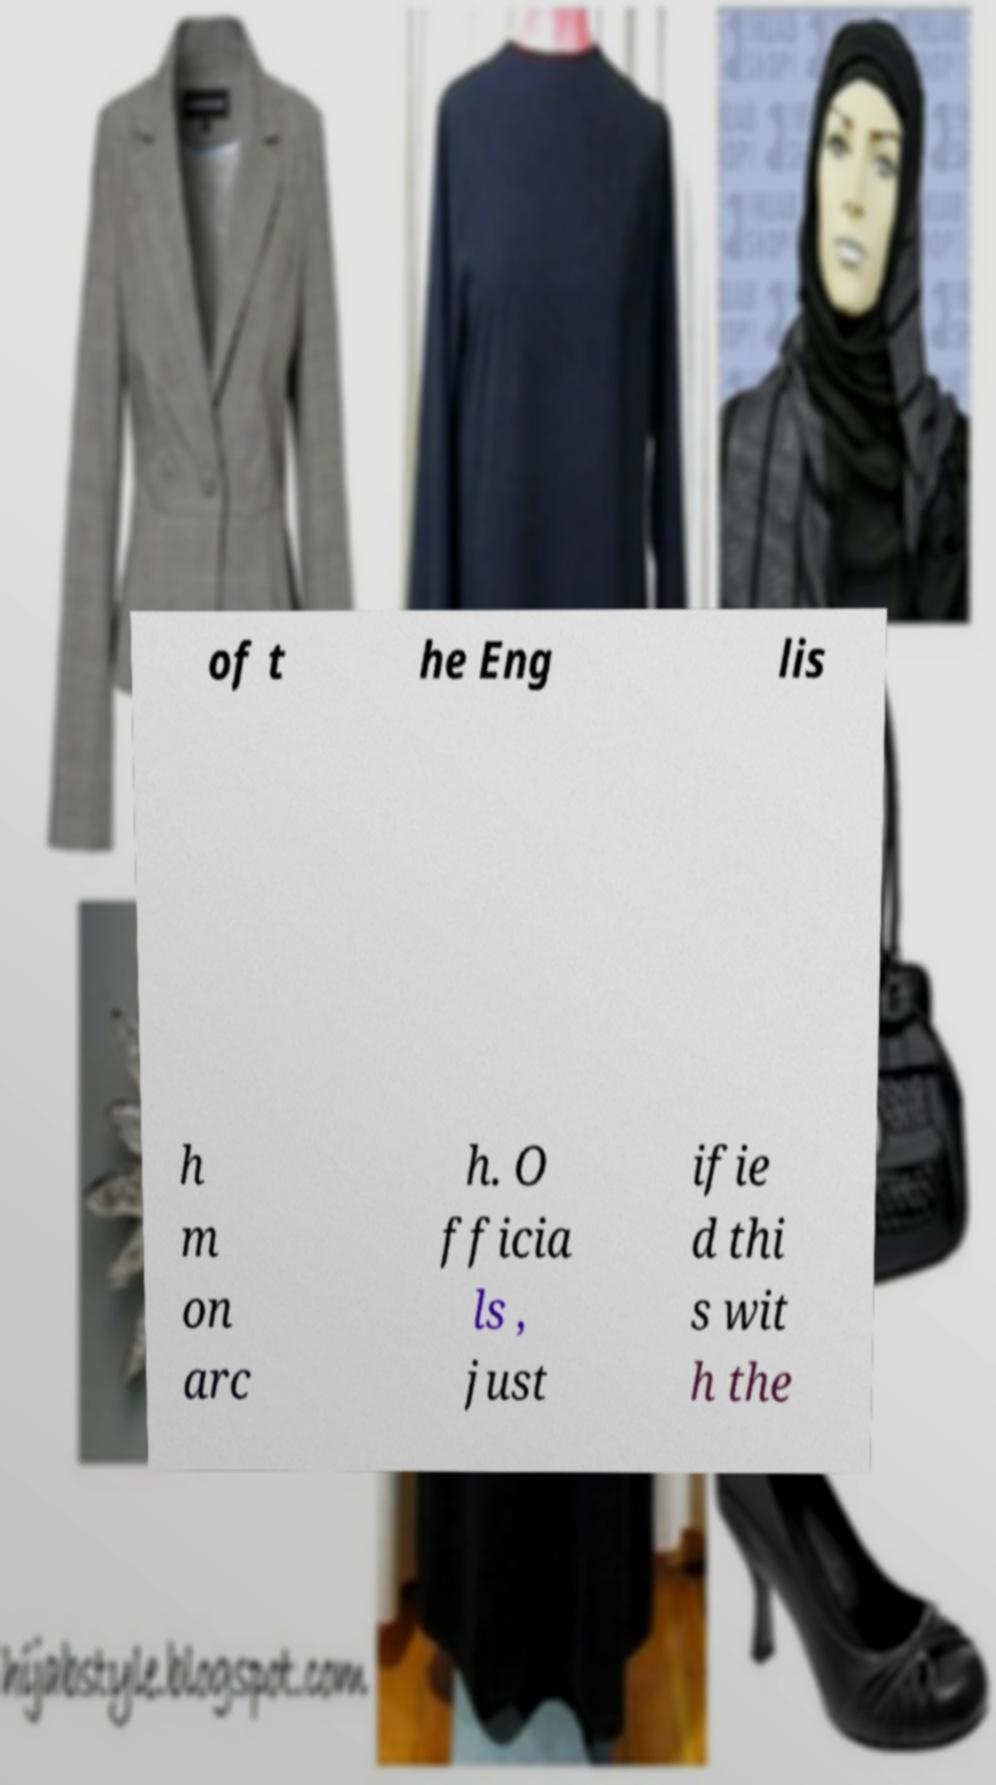I need the written content from this picture converted into text. Can you do that? of t he Eng lis h m on arc h. O fficia ls , just ifie d thi s wit h the 